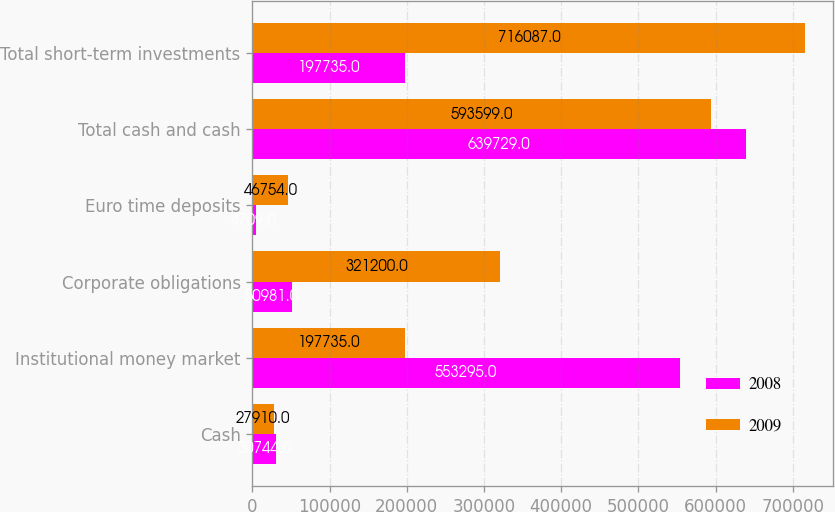Convert chart to OTSL. <chart><loc_0><loc_0><loc_500><loc_500><stacked_bar_chart><ecel><fcel>Cash<fcel>Institutional money market<fcel>Corporate obligations<fcel>Euro time deposits<fcel>Total cash and cash<fcel>Total short-term investments<nl><fcel>2008<fcel>30744<fcel>553295<fcel>50981<fcel>4709<fcel>639729<fcel>197735<nl><fcel>2009<fcel>27910<fcel>197735<fcel>321200<fcel>46754<fcel>593599<fcel>716087<nl></chart> 